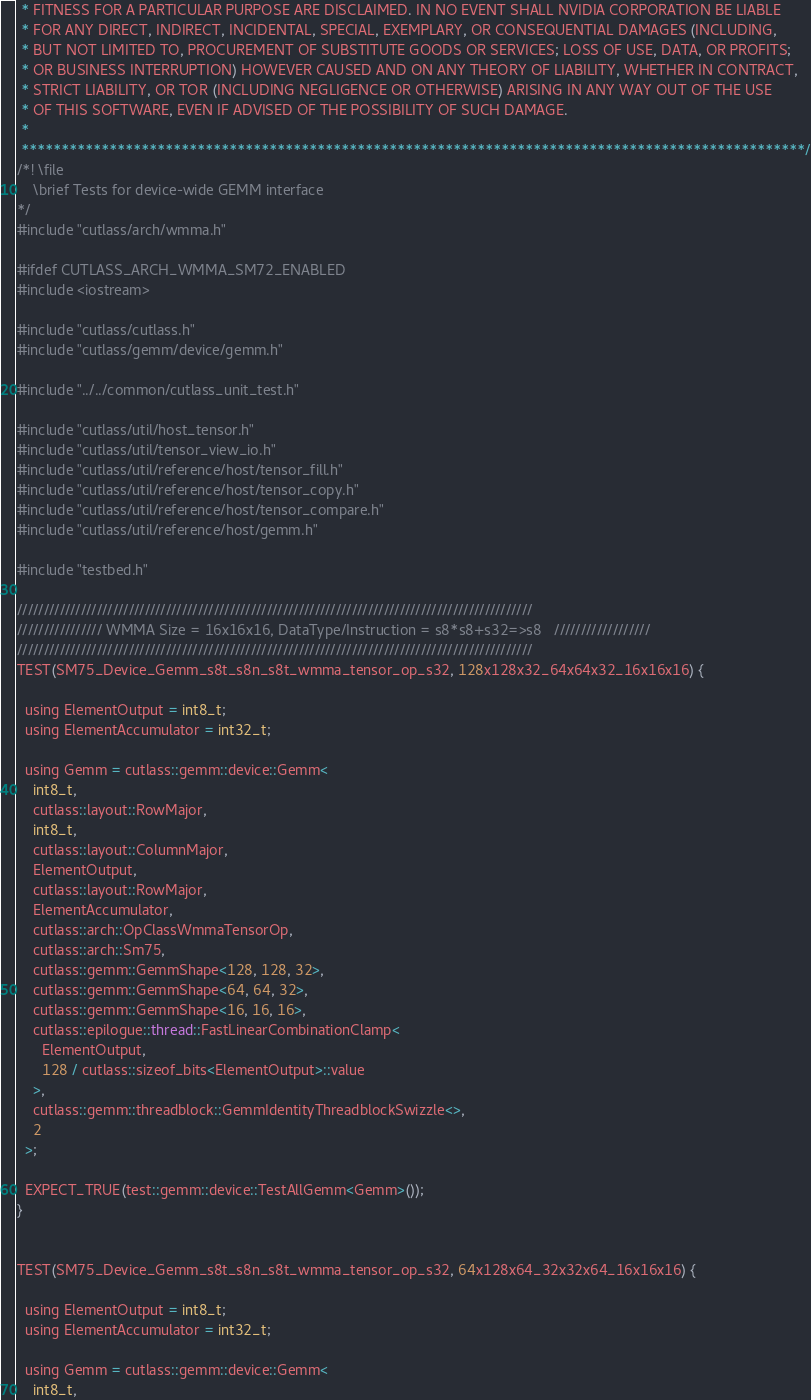<code> <loc_0><loc_0><loc_500><loc_500><_Cuda_> * FITNESS FOR A PARTICULAR PURPOSE ARE DISCLAIMED. IN NO EVENT SHALL NVIDIA CORPORATION BE LIABLE
 * FOR ANY DIRECT, INDIRECT, INCIDENTAL, SPECIAL, EXEMPLARY, OR CONSEQUENTIAL DAMAGES (INCLUDING,
 * BUT NOT LIMITED TO, PROCUREMENT OF SUBSTITUTE GOODS OR SERVICES; LOSS OF USE, DATA, OR PROFITS;
 * OR BUSINESS INTERRUPTION) HOWEVER CAUSED AND ON ANY THEORY OF LIABILITY, WHETHER IN CONTRACT,
 * STRICT LIABILITY, OR TOR (INCLUDING NEGLIGENCE OR OTHERWISE) ARISING IN ANY WAY OUT OF THE USE
 * OF THIS SOFTWARE, EVEN IF ADVISED OF THE POSSIBILITY OF SUCH DAMAGE.
 *
 **************************************************************************************************/
/*! \file
    \brief Tests for device-wide GEMM interface
*/
#include "cutlass/arch/wmma.h"

#ifdef CUTLASS_ARCH_WMMA_SM72_ENABLED
#include <iostream>

#include "cutlass/cutlass.h"
#include "cutlass/gemm/device/gemm.h"

#include "../../common/cutlass_unit_test.h"

#include "cutlass/util/host_tensor.h"
#include "cutlass/util/tensor_view_io.h"
#include "cutlass/util/reference/host/tensor_fill.h"
#include "cutlass/util/reference/host/tensor_copy.h"
#include "cutlass/util/reference/host/tensor_compare.h"
#include "cutlass/util/reference/host/gemm.h"

#include "testbed.h"

/////////////////////////////////////////////////////////////////////////////////////////////////
//////////////// WMMA Size = 16x16x16, DataType/Instruction = s8*s8+s32=>s8   //////////////////
/////////////////////////////////////////////////////////////////////////////////////////////////
TEST(SM75_Device_Gemm_s8t_s8n_s8t_wmma_tensor_op_s32, 128x128x32_64x64x32_16x16x16) {

  using ElementOutput = int8_t;
  using ElementAccumulator = int32_t;

  using Gemm = cutlass::gemm::device::Gemm<
    int8_t,
    cutlass::layout::RowMajor,
    int8_t,
    cutlass::layout::ColumnMajor,
    ElementOutput,
    cutlass::layout::RowMajor,
    ElementAccumulator,
    cutlass::arch::OpClassWmmaTensorOp,
    cutlass::arch::Sm75,
    cutlass::gemm::GemmShape<128, 128, 32>,
    cutlass::gemm::GemmShape<64, 64, 32>,
    cutlass::gemm::GemmShape<16, 16, 16>,
    cutlass::epilogue::thread::FastLinearCombinationClamp<
      ElementOutput,
      128 / cutlass::sizeof_bits<ElementOutput>::value
    >,
    cutlass::gemm::threadblock::GemmIdentityThreadblockSwizzle<>,
    2
  >;

  EXPECT_TRUE(test::gemm::device::TestAllGemm<Gemm>());
}


TEST(SM75_Device_Gemm_s8t_s8n_s8t_wmma_tensor_op_s32, 64x128x64_32x32x64_16x16x16) {

  using ElementOutput = int8_t;
  using ElementAccumulator = int32_t;

  using Gemm = cutlass::gemm::device::Gemm<
    int8_t,</code> 